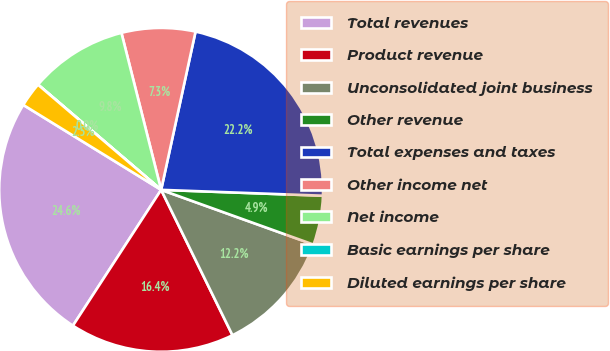<chart> <loc_0><loc_0><loc_500><loc_500><pie_chart><fcel>Total revenues<fcel>Product revenue<fcel>Unconsolidated joint business<fcel>Other revenue<fcel>Total expenses and taxes<fcel>Other income net<fcel>Net income<fcel>Basic earnings per share<fcel>Diluted earnings per share<nl><fcel>24.62%<fcel>16.43%<fcel>12.25%<fcel>4.91%<fcel>22.17%<fcel>7.35%<fcel>9.8%<fcel>0.01%<fcel>2.46%<nl></chart> 